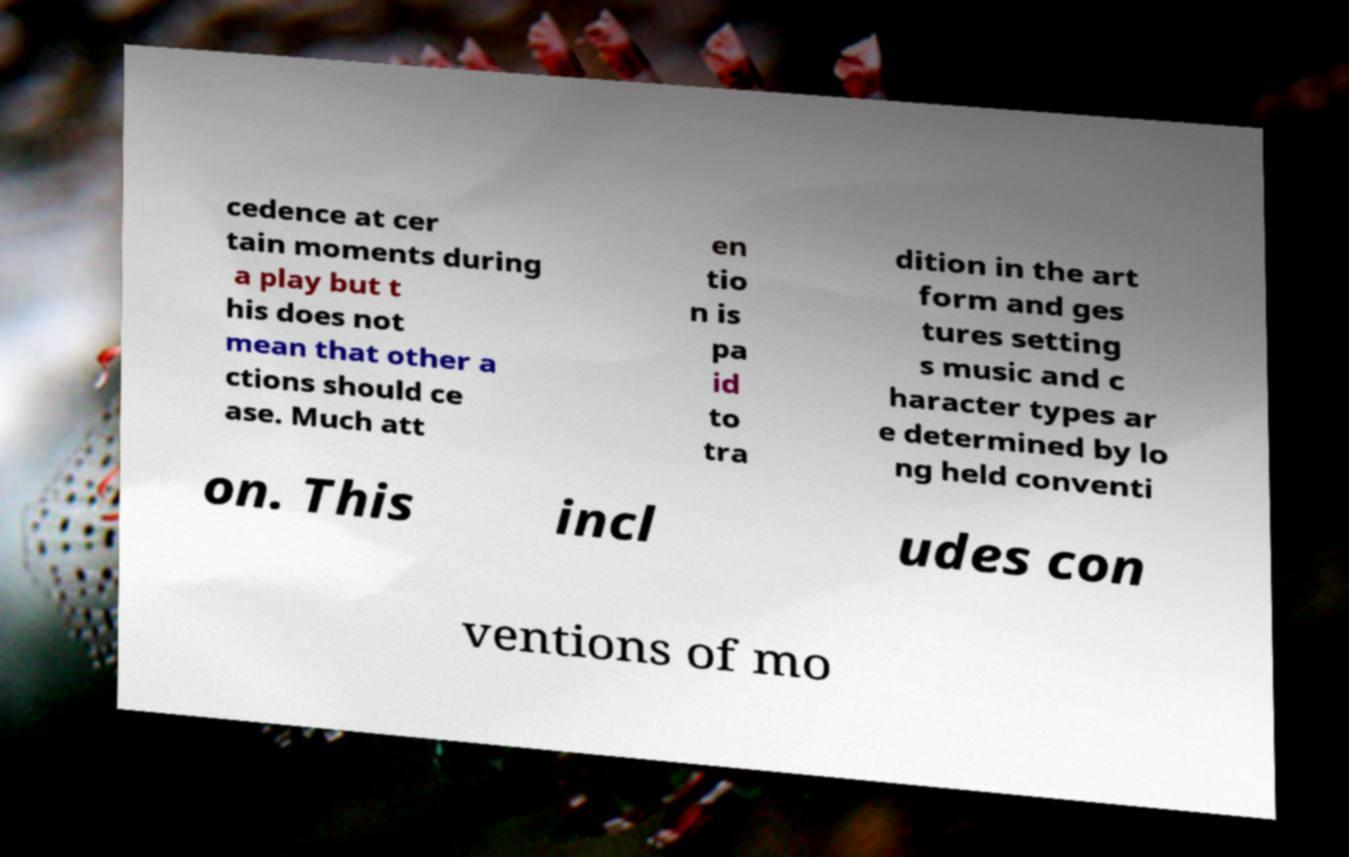Can you read and provide the text displayed in the image?This photo seems to have some interesting text. Can you extract and type it out for me? cedence at cer tain moments during a play but t his does not mean that other a ctions should ce ase. Much att en tio n is pa id to tra dition in the art form and ges tures setting s music and c haracter types ar e determined by lo ng held conventi on. This incl udes con ventions of mo 